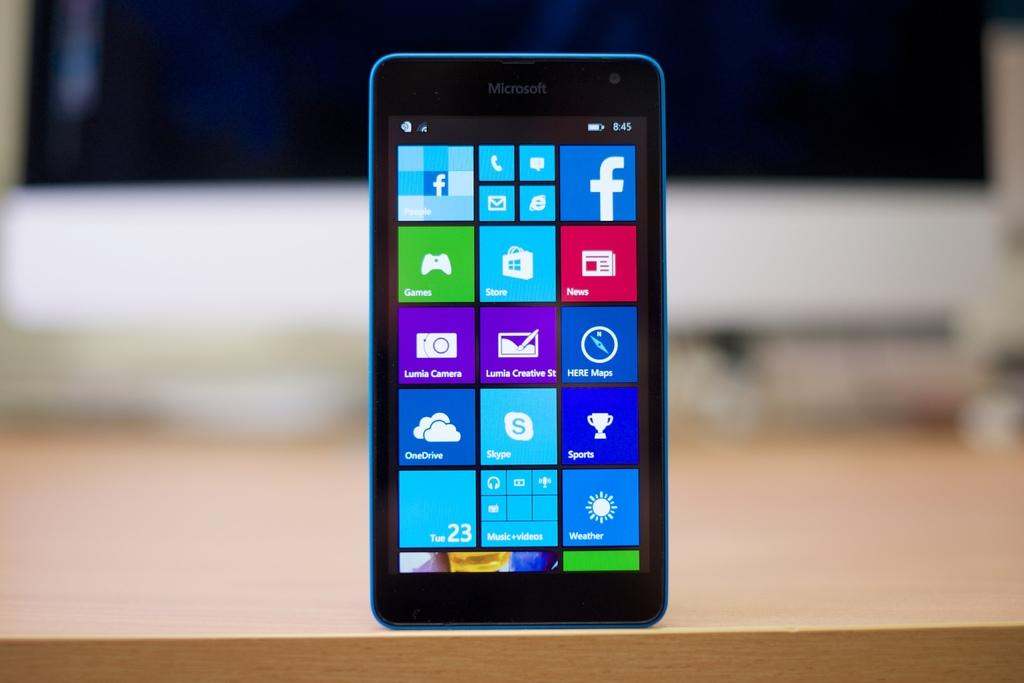<image>
Summarize the visual content of the image. A blue phone from the Microsoft brand is on the table. 